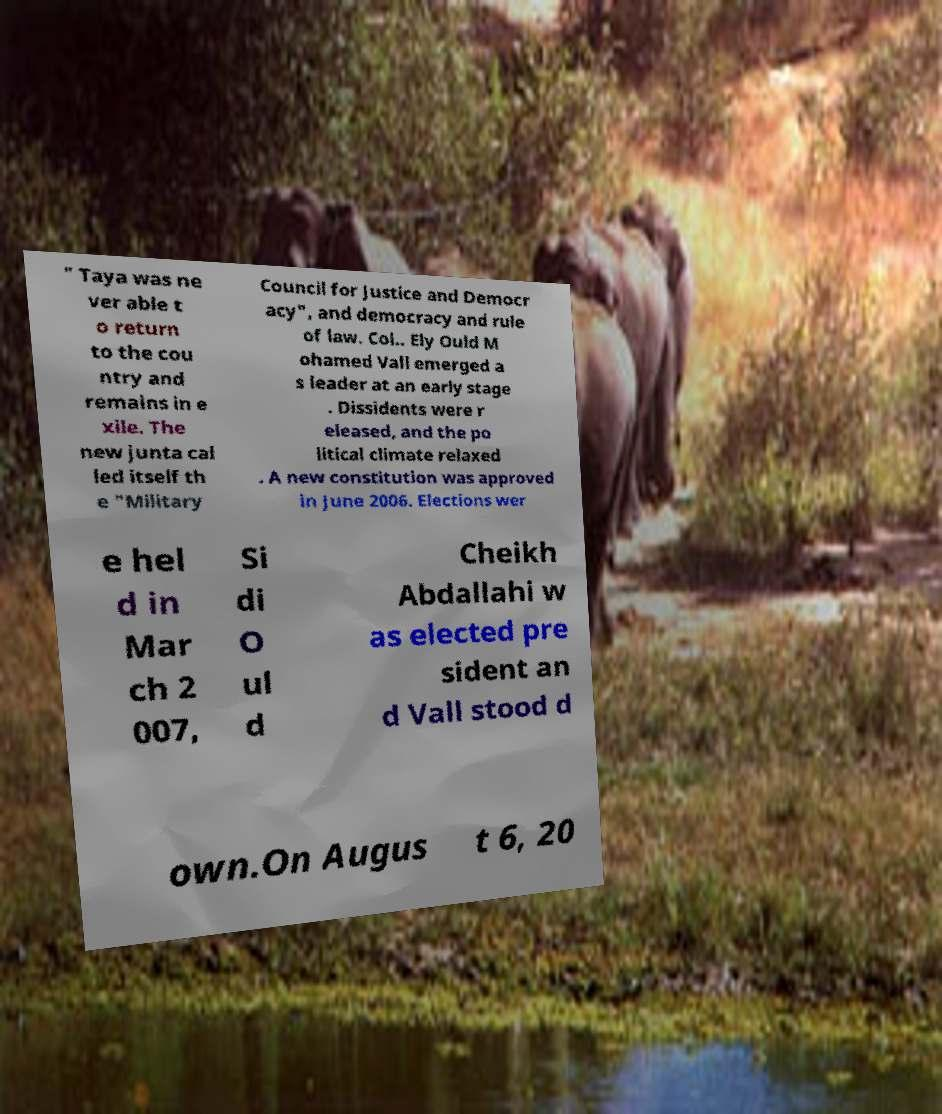There's text embedded in this image that I need extracted. Can you transcribe it verbatim? " Taya was ne ver able t o return to the cou ntry and remains in e xile. The new junta cal led itself th e "Military Council for Justice and Democr acy", and democracy and rule of law. Col.. Ely Ould M ohamed Vall emerged a s leader at an early stage . Dissidents were r eleased, and the po litical climate relaxed . A new constitution was approved in June 2006. Elections wer e hel d in Mar ch 2 007, Si di O ul d Cheikh Abdallahi w as elected pre sident an d Vall stood d own.On Augus t 6, 20 